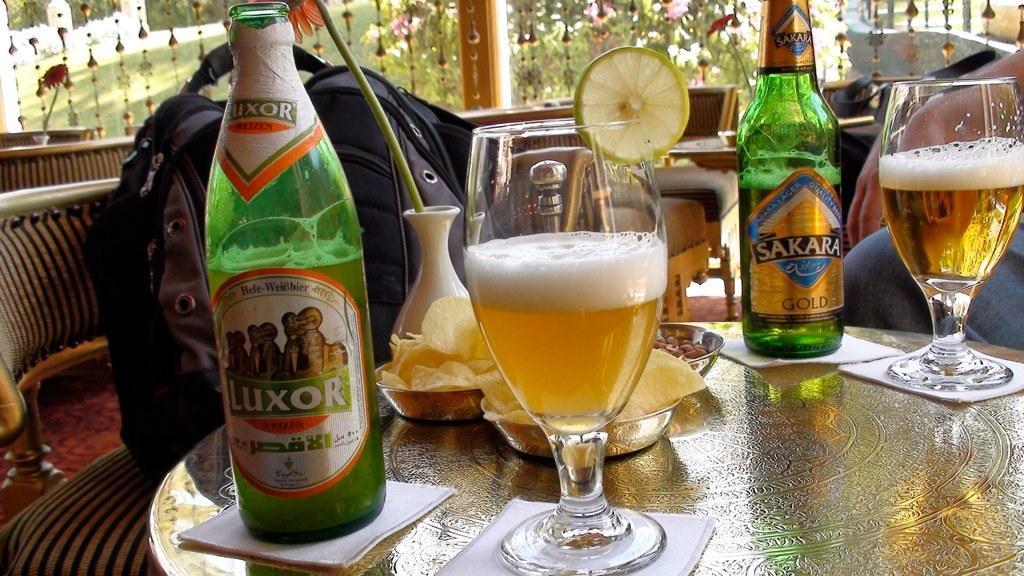In one or two sentences, can you explain what this image depicts? In this image i can see a person sitting on a chair in front of a table, on the table I can see few beer bottles,few glasses and few plates with snacks in them ,I can see a bag on the chair. In the background I can see few chairs, a flower and few trees. 